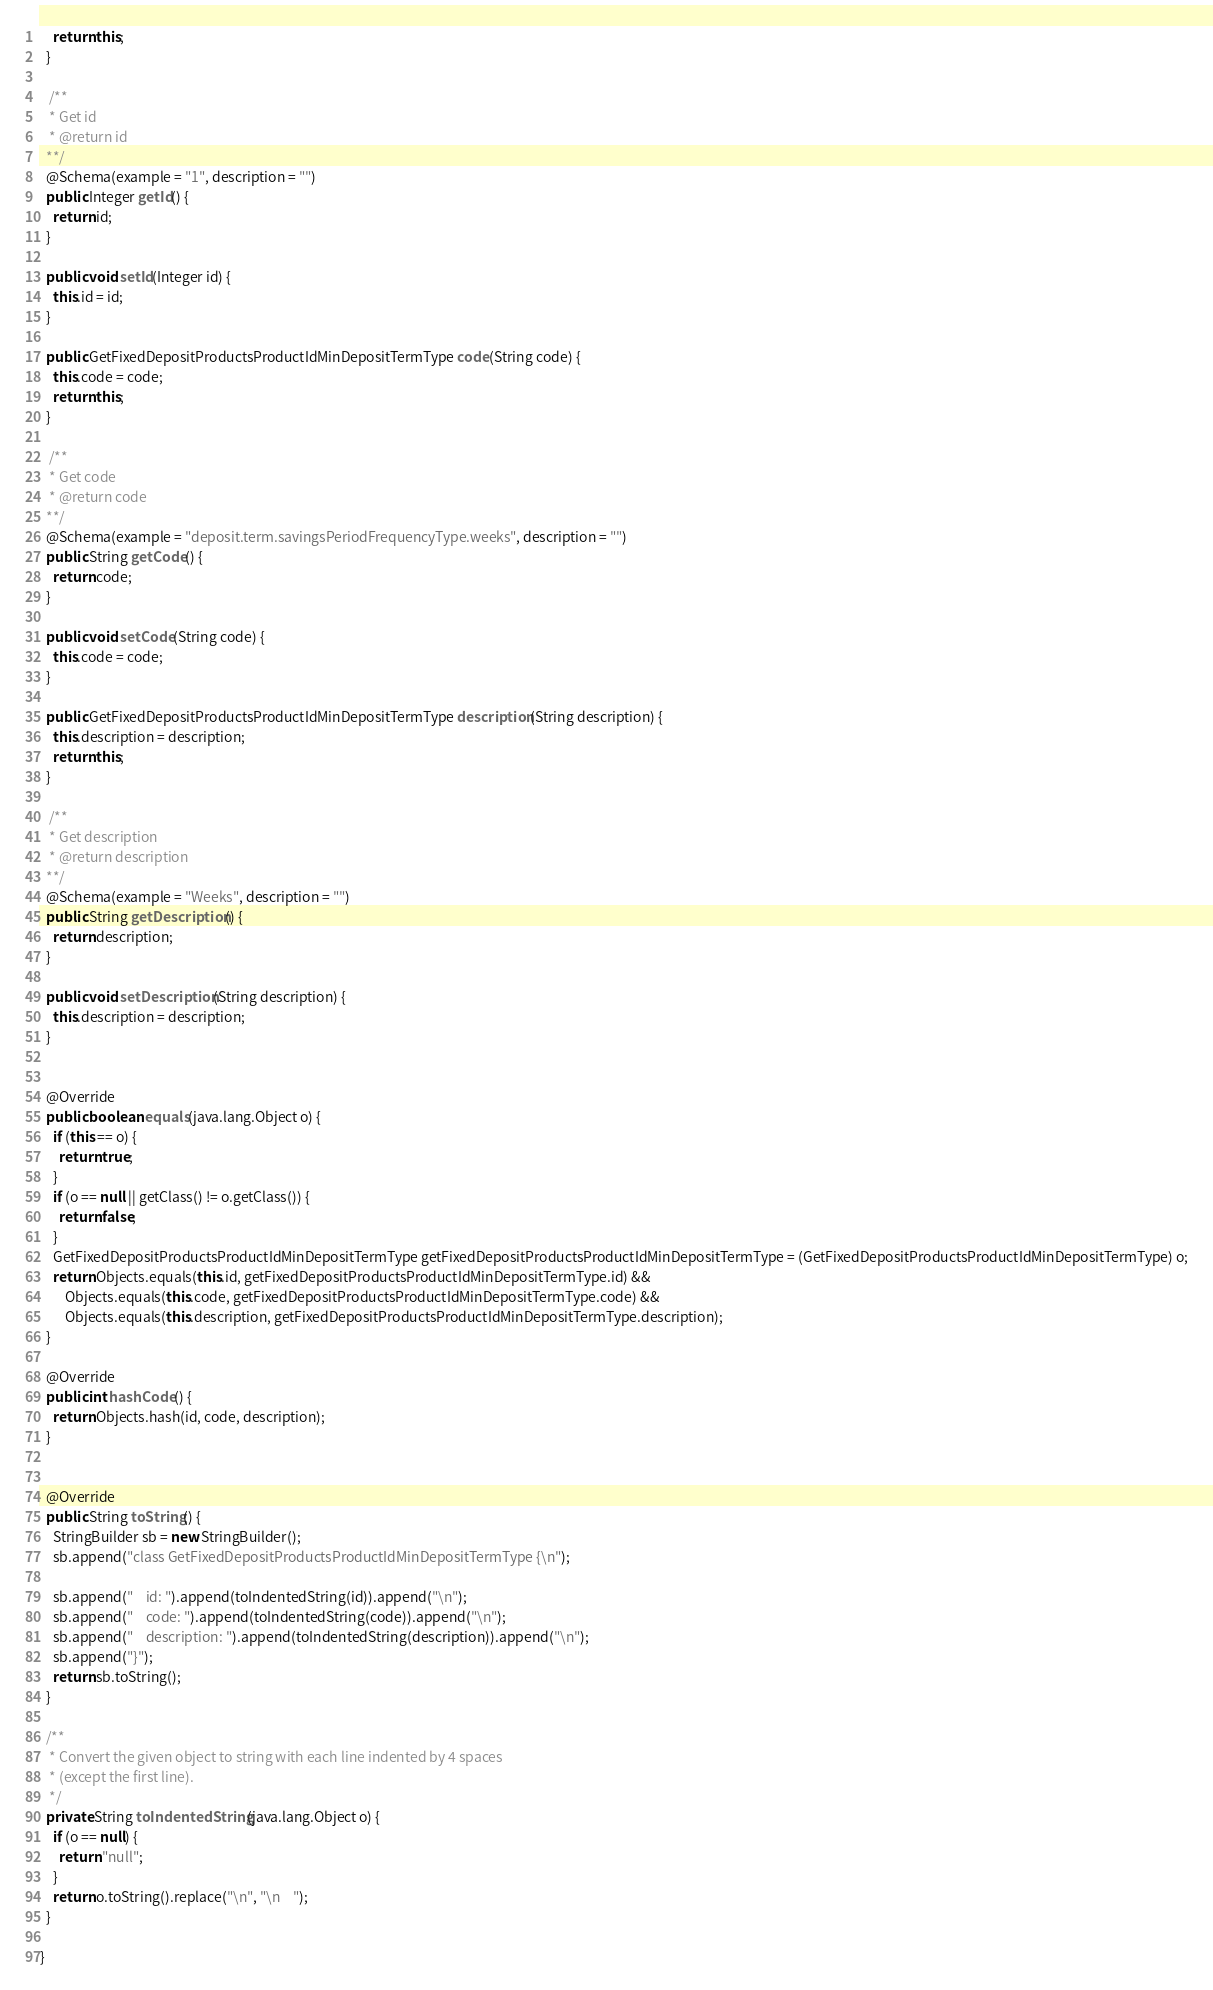<code> <loc_0><loc_0><loc_500><loc_500><_Java_>    return this;
  }

   /**
   * Get id
   * @return id
  **/
  @Schema(example = "1", description = "")
  public Integer getId() {
    return id;
  }

  public void setId(Integer id) {
    this.id = id;
  }

  public GetFixedDepositProductsProductIdMinDepositTermType code(String code) {
    this.code = code;
    return this;
  }

   /**
   * Get code
   * @return code
  **/
  @Schema(example = "deposit.term.savingsPeriodFrequencyType.weeks", description = "")
  public String getCode() {
    return code;
  }

  public void setCode(String code) {
    this.code = code;
  }

  public GetFixedDepositProductsProductIdMinDepositTermType description(String description) {
    this.description = description;
    return this;
  }

   /**
   * Get description
   * @return description
  **/
  @Schema(example = "Weeks", description = "")
  public String getDescription() {
    return description;
  }

  public void setDescription(String description) {
    this.description = description;
  }


  @Override
  public boolean equals(java.lang.Object o) {
    if (this == o) {
      return true;
    }
    if (o == null || getClass() != o.getClass()) {
      return false;
    }
    GetFixedDepositProductsProductIdMinDepositTermType getFixedDepositProductsProductIdMinDepositTermType = (GetFixedDepositProductsProductIdMinDepositTermType) o;
    return Objects.equals(this.id, getFixedDepositProductsProductIdMinDepositTermType.id) &&
        Objects.equals(this.code, getFixedDepositProductsProductIdMinDepositTermType.code) &&
        Objects.equals(this.description, getFixedDepositProductsProductIdMinDepositTermType.description);
  }

  @Override
  public int hashCode() {
    return Objects.hash(id, code, description);
  }


  @Override
  public String toString() {
    StringBuilder sb = new StringBuilder();
    sb.append("class GetFixedDepositProductsProductIdMinDepositTermType {\n");
    
    sb.append("    id: ").append(toIndentedString(id)).append("\n");
    sb.append("    code: ").append(toIndentedString(code)).append("\n");
    sb.append("    description: ").append(toIndentedString(description)).append("\n");
    sb.append("}");
    return sb.toString();
  }

  /**
   * Convert the given object to string with each line indented by 4 spaces
   * (except the first line).
   */
  private String toIndentedString(java.lang.Object o) {
    if (o == null) {
      return "null";
    }
    return o.toString().replace("\n", "\n    ");
  }

}
</code> 